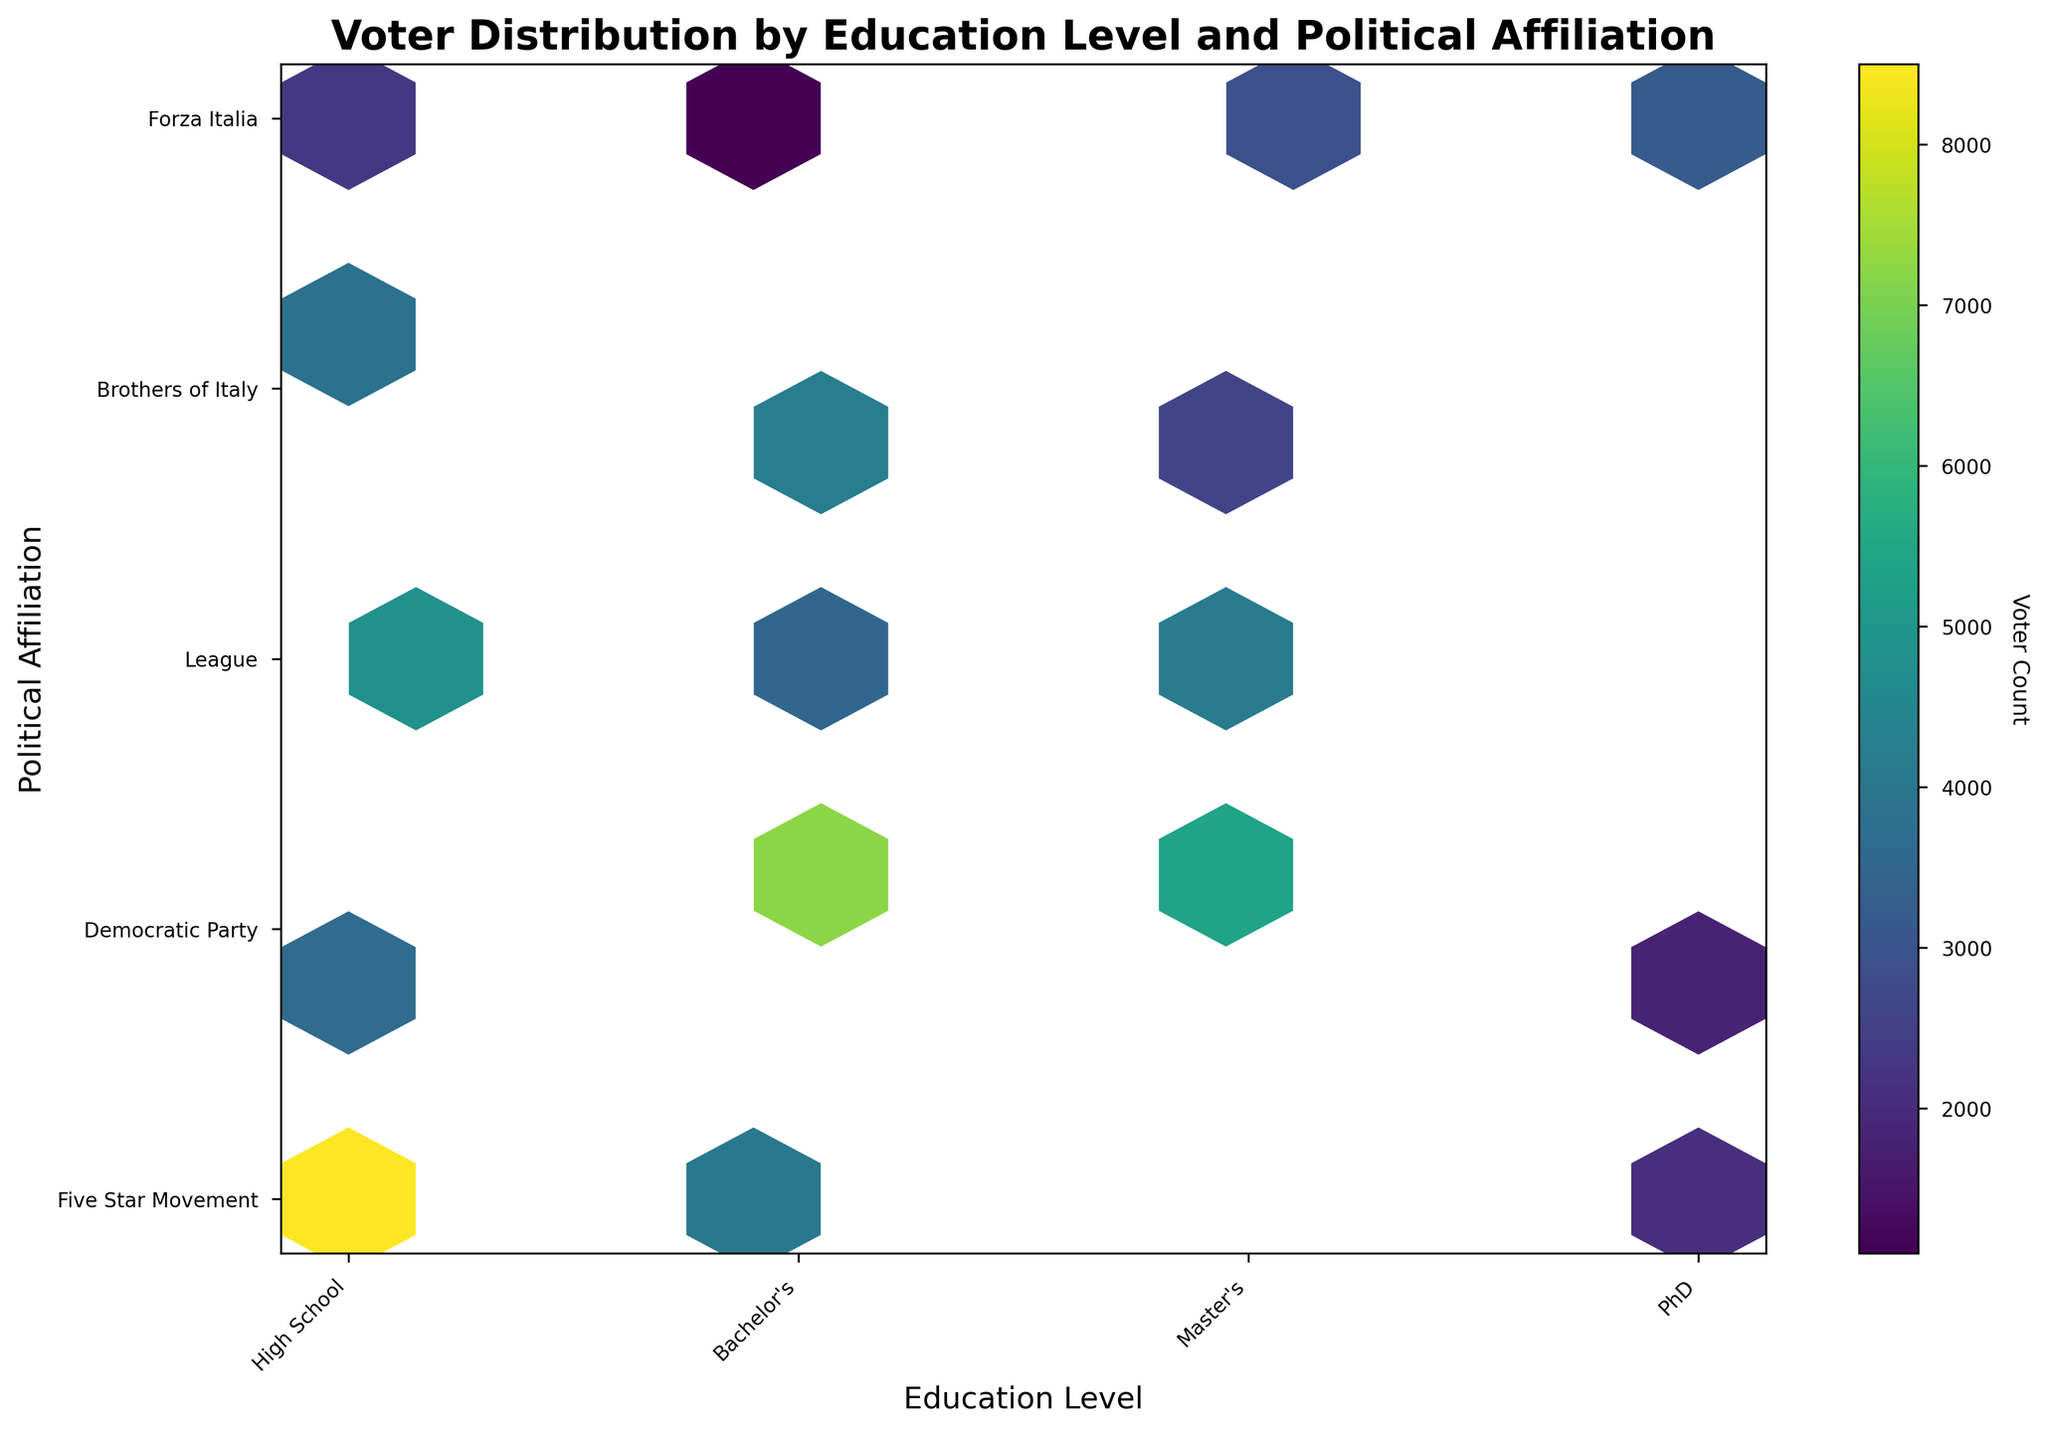What is the title of the hexbin plot? The title of the plot is displayed at the top of the figure and provides a summary of what the plot represents.
Answer: Voter Distribution by Education Level and Political Affiliation How many education levels are represented in the plot? The x-axis represents the education levels, and you can count the different labels on this axis.
Answer: Four Which political party has the highest concentration of voters with a Bachelor's degree? Look at the hexagons on the y-axis at the position corresponding to the Bachelor's degree and identify which hexagon has the highest color intensity, correlating to voter count.
Answer: Democratic Party What is the range of voter counts represented in the color bar? The color bar on the right of the plot indicates the range of voter counts, starting from its minimum value to its maximum.
Answer: 1100 to 8500 Which education level has the highest number of voters for the League? Identify the hexagon with the highest intensity (darkest color) along the y-axis level corresponding to the League on the plot.
Answer: Master's Compare the voter counts for the Five Star Movement between PhD and Bachelor's degree. Which one is higher? Locate the hexagons for the Five Star Movement on the master's and bachelor's degree positions on the y-axis, then compare their color intensities.
Answer: Bachelor's How does the voter distribution of the Democratic Party compare between voters with a High School education and voters with a Master's degree? Check the hexbin plot for the Democratic Party at both the High School and Master's degree levels and compare the color intensities of the hexagons.
Answer: Higher for Master's What educational level has the least voter count for the Brothers of Italy? Identify the lowest intensity hexagon along the y-axis level corresponding to the Brothers of Italy on the plot.
Answer: PhD Which political party shows a consistent increase in voter count with increasing education levels, if any? Look for political parties along the y-axis and observe the hexagons' intensities at increasing education levels to identify any consistent increase.
Answer: None Is there a visible trend between education level and voter count for the League? Observe the position of the hexagons for the League along the education levels and determine if there's a trend (increase or decrease) in color intensity as education level changes.
Answer: Voter count generally increases with education level 